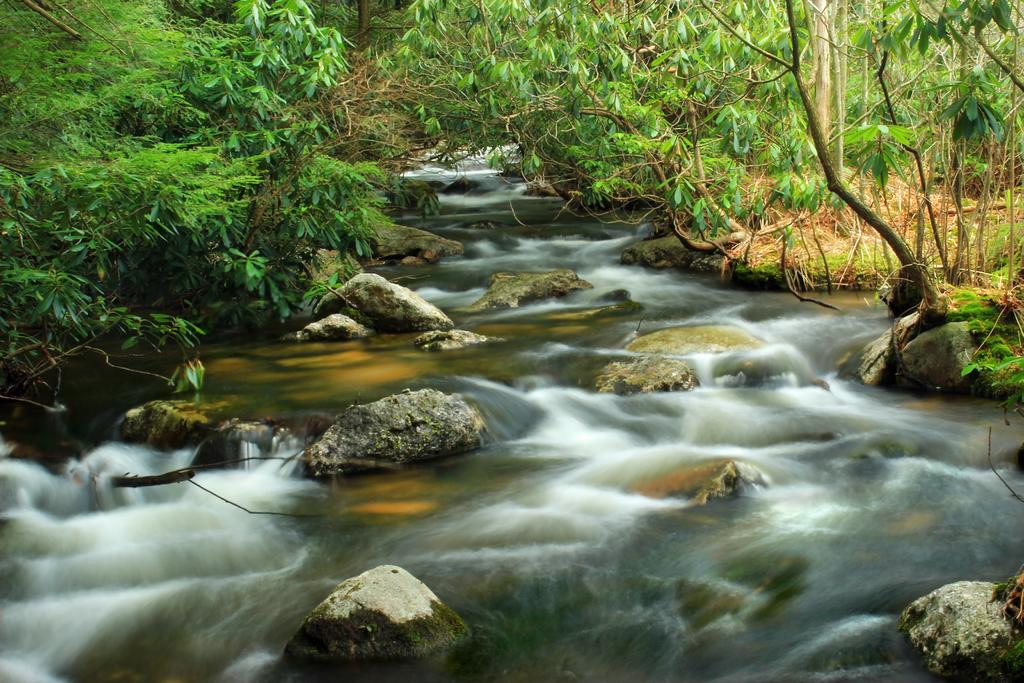What type of natural feature is present in the image? There is a water body in the image. What other elements can be seen in the image? There are stones, plants, grass, and a group of trees in the image. What type of bread can be seen growing among the trees in the image? There is no bread present in the image; it features a water body, stones, plants, grass, and a group of trees. 